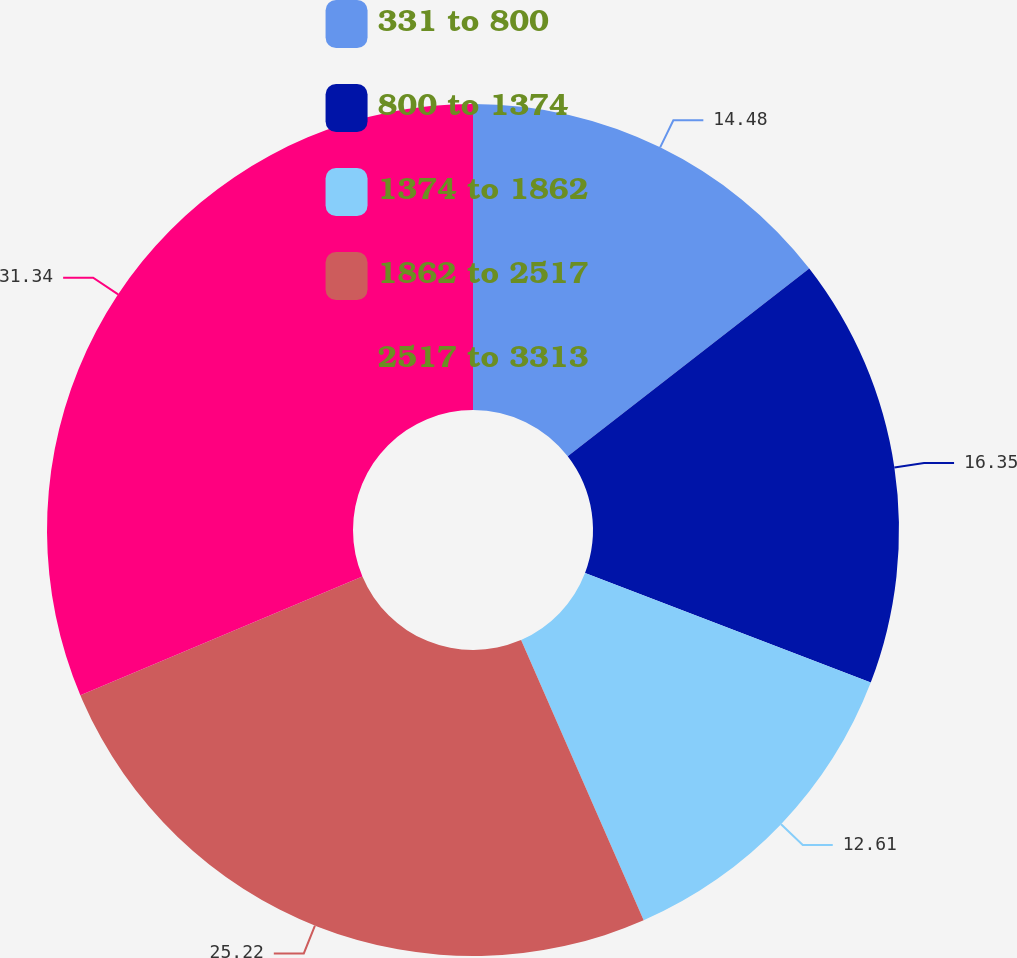<chart> <loc_0><loc_0><loc_500><loc_500><pie_chart><fcel>331 to 800<fcel>800 to 1374<fcel>1374 to 1862<fcel>1862 to 2517<fcel>2517 to 3313<nl><fcel>14.48%<fcel>16.35%<fcel>12.61%<fcel>25.22%<fcel>31.34%<nl></chart> 